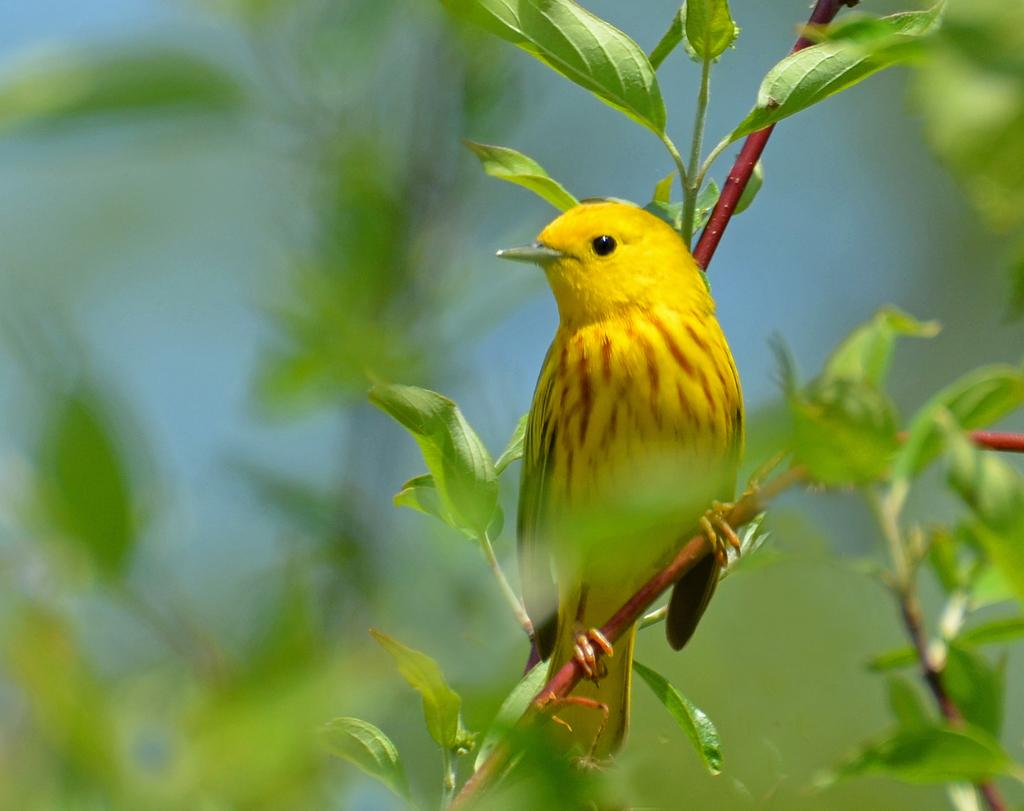What is the main subject in the center of the image? There is a bird in the center of the image. What can be seen in the background of the image? There are plants in the background of the image. What type of sail can be seen in the image? There is no sail present in the image; it features a bird and plants in the background. 